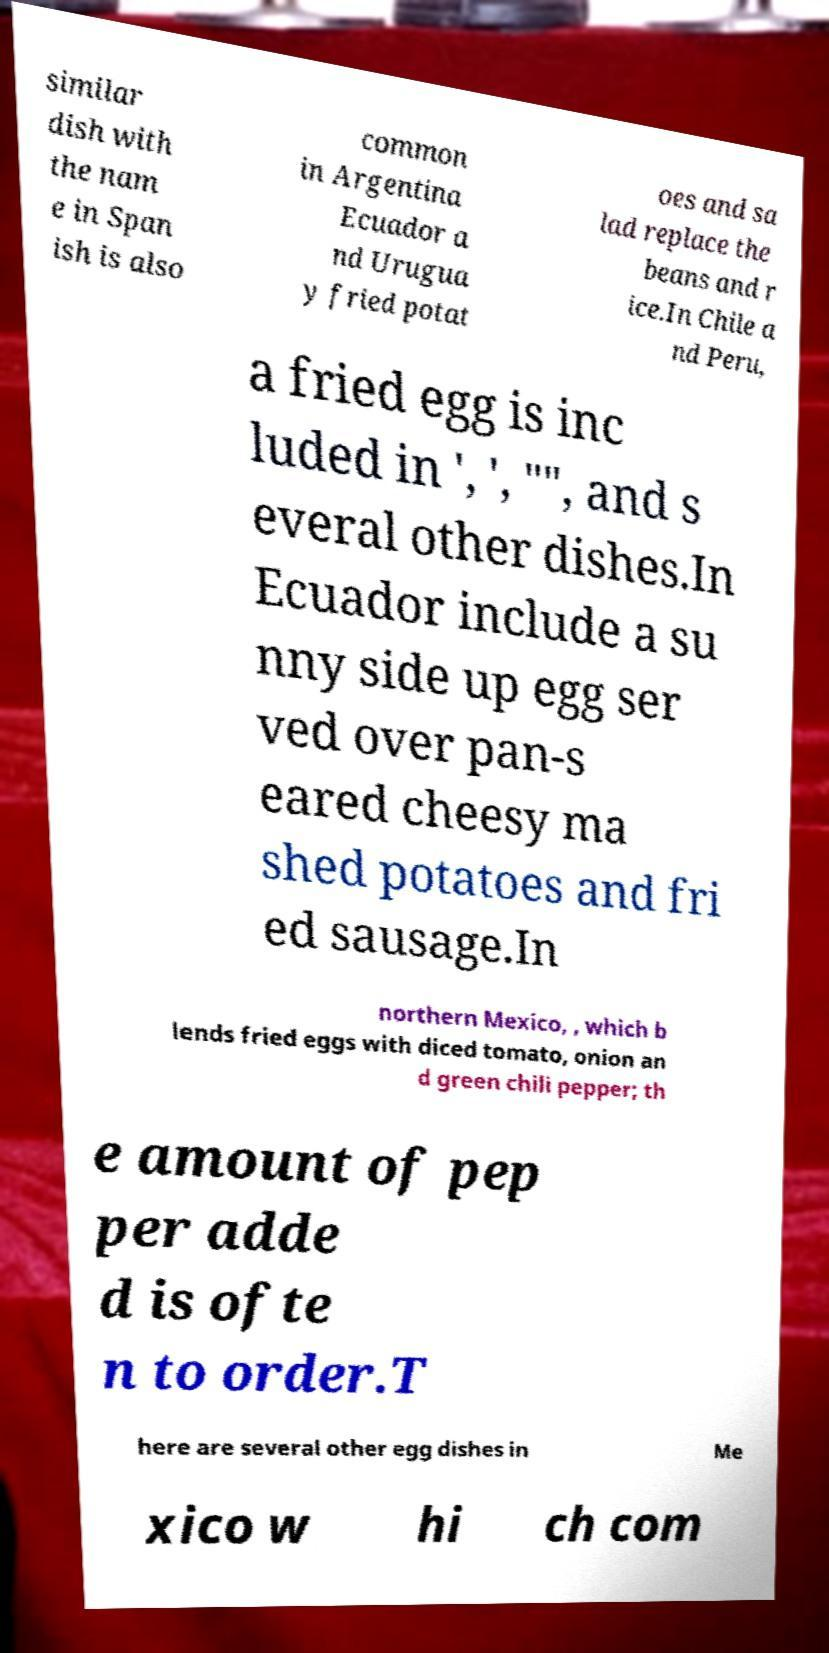Please read and relay the text visible in this image. What does it say? similar dish with the nam e in Span ish is also common in Argentina Ecuador a nd Urugua y fried potat oes and sa lad replace the beans and r ice.In Chile a nd Peru, a fried egg is inc luded in ', ', "", and s everal other dishes.In Ecuador include a su nny side up egg ser ved over pan-s eared cheesy ma shed potatoes and fri ed sausage.In northern Mexico, , which b lends fried eggs with diced tomato, onion an d green chili pepper; th e amount of pep per adde d is ofte n to order.T here are several other egg dishes in Me xico w hi ch com 